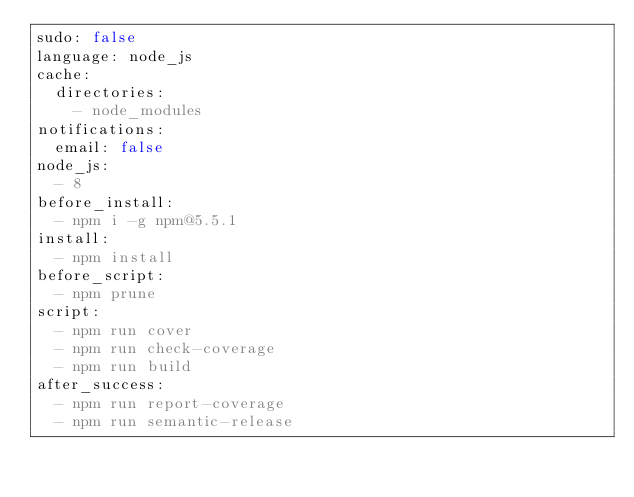Convert code to text. <code><loc_0><loc_0><loc_500><loc_500><_YAML_>sudo: false
language: node_js
cache:
  directories:
    - node_modules
notifications:
  email: false
node_js:
  - 8
before_install:
  - npm i -g npm@5.5.1
install:
  - npm install
before_script:
  - npm prune
script:
  - npm run cover
  - npm run check-coverage
  - npm run build
after_success:
  - npm run report-coverage
  - npm run semantic-release
</code> 